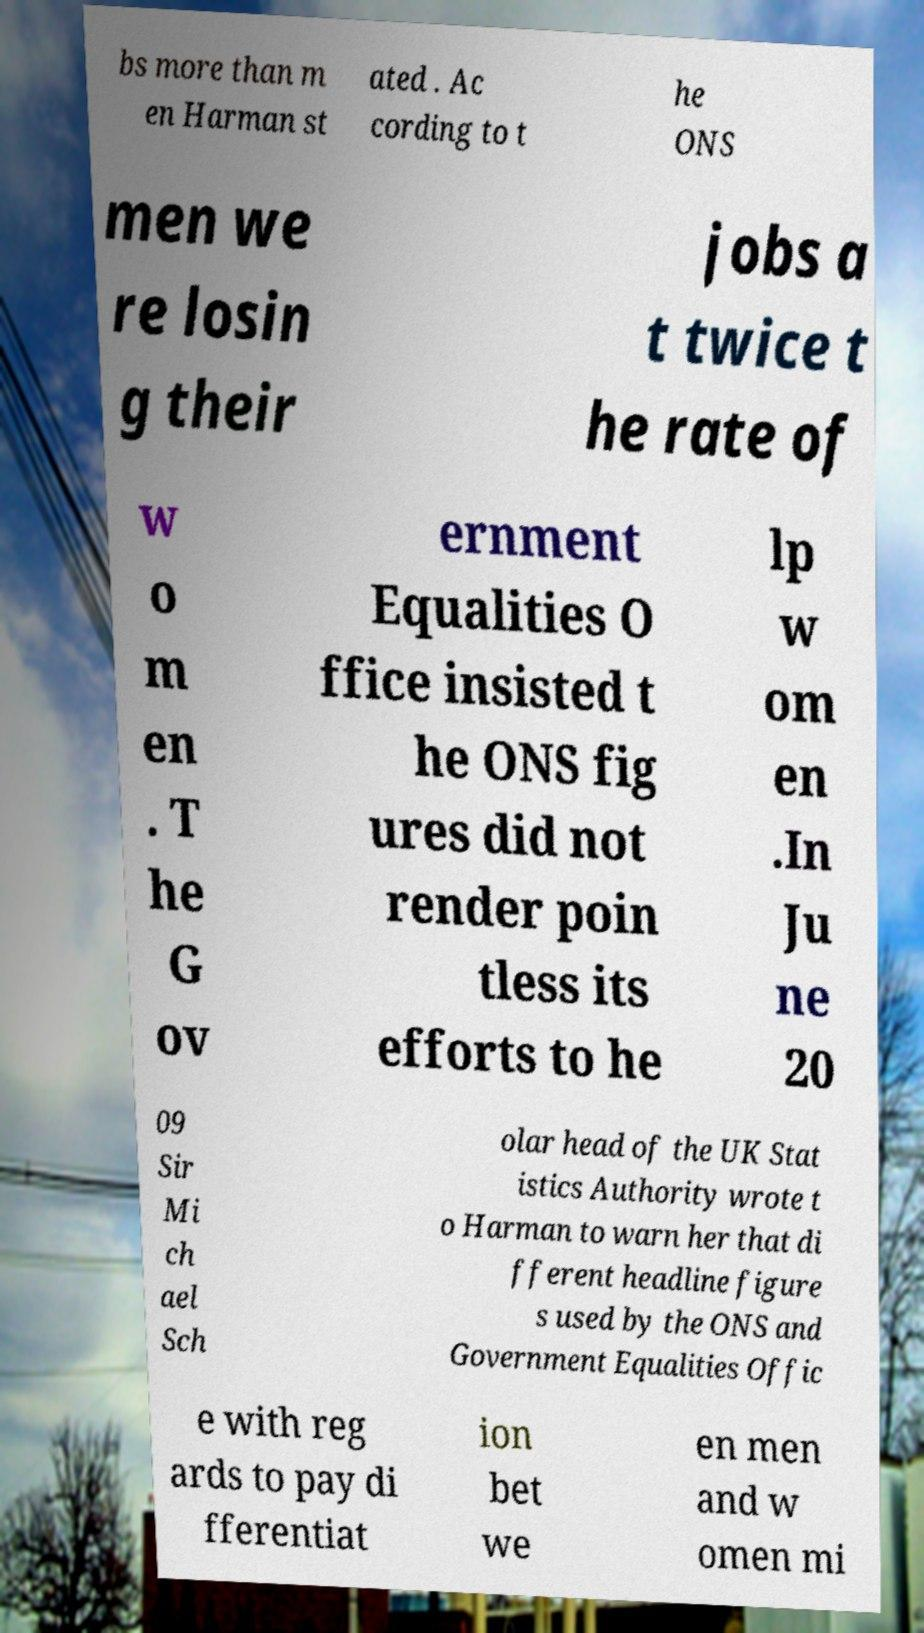Can you accurately transcribe the text from the provided image for me? bs more than m en Harman st ated . Ac cording to t he ONS men we re losin g their jobs a t twice t he rate of w o m en . T he G ov ernment Equalities O ffice insisted t he ONS fig ures did not render poin tless its efforts to he lp w om en .In Ju ne 20 09 Sir Mi ch ael Sch olar head of the UK Stat istics Authority wrote t o Harman to warn her that di fferent headline figure s used by the ONS and Government Equalities Offic e with reg ards to pay di fferentiat ion bet we en men and w omen mi 